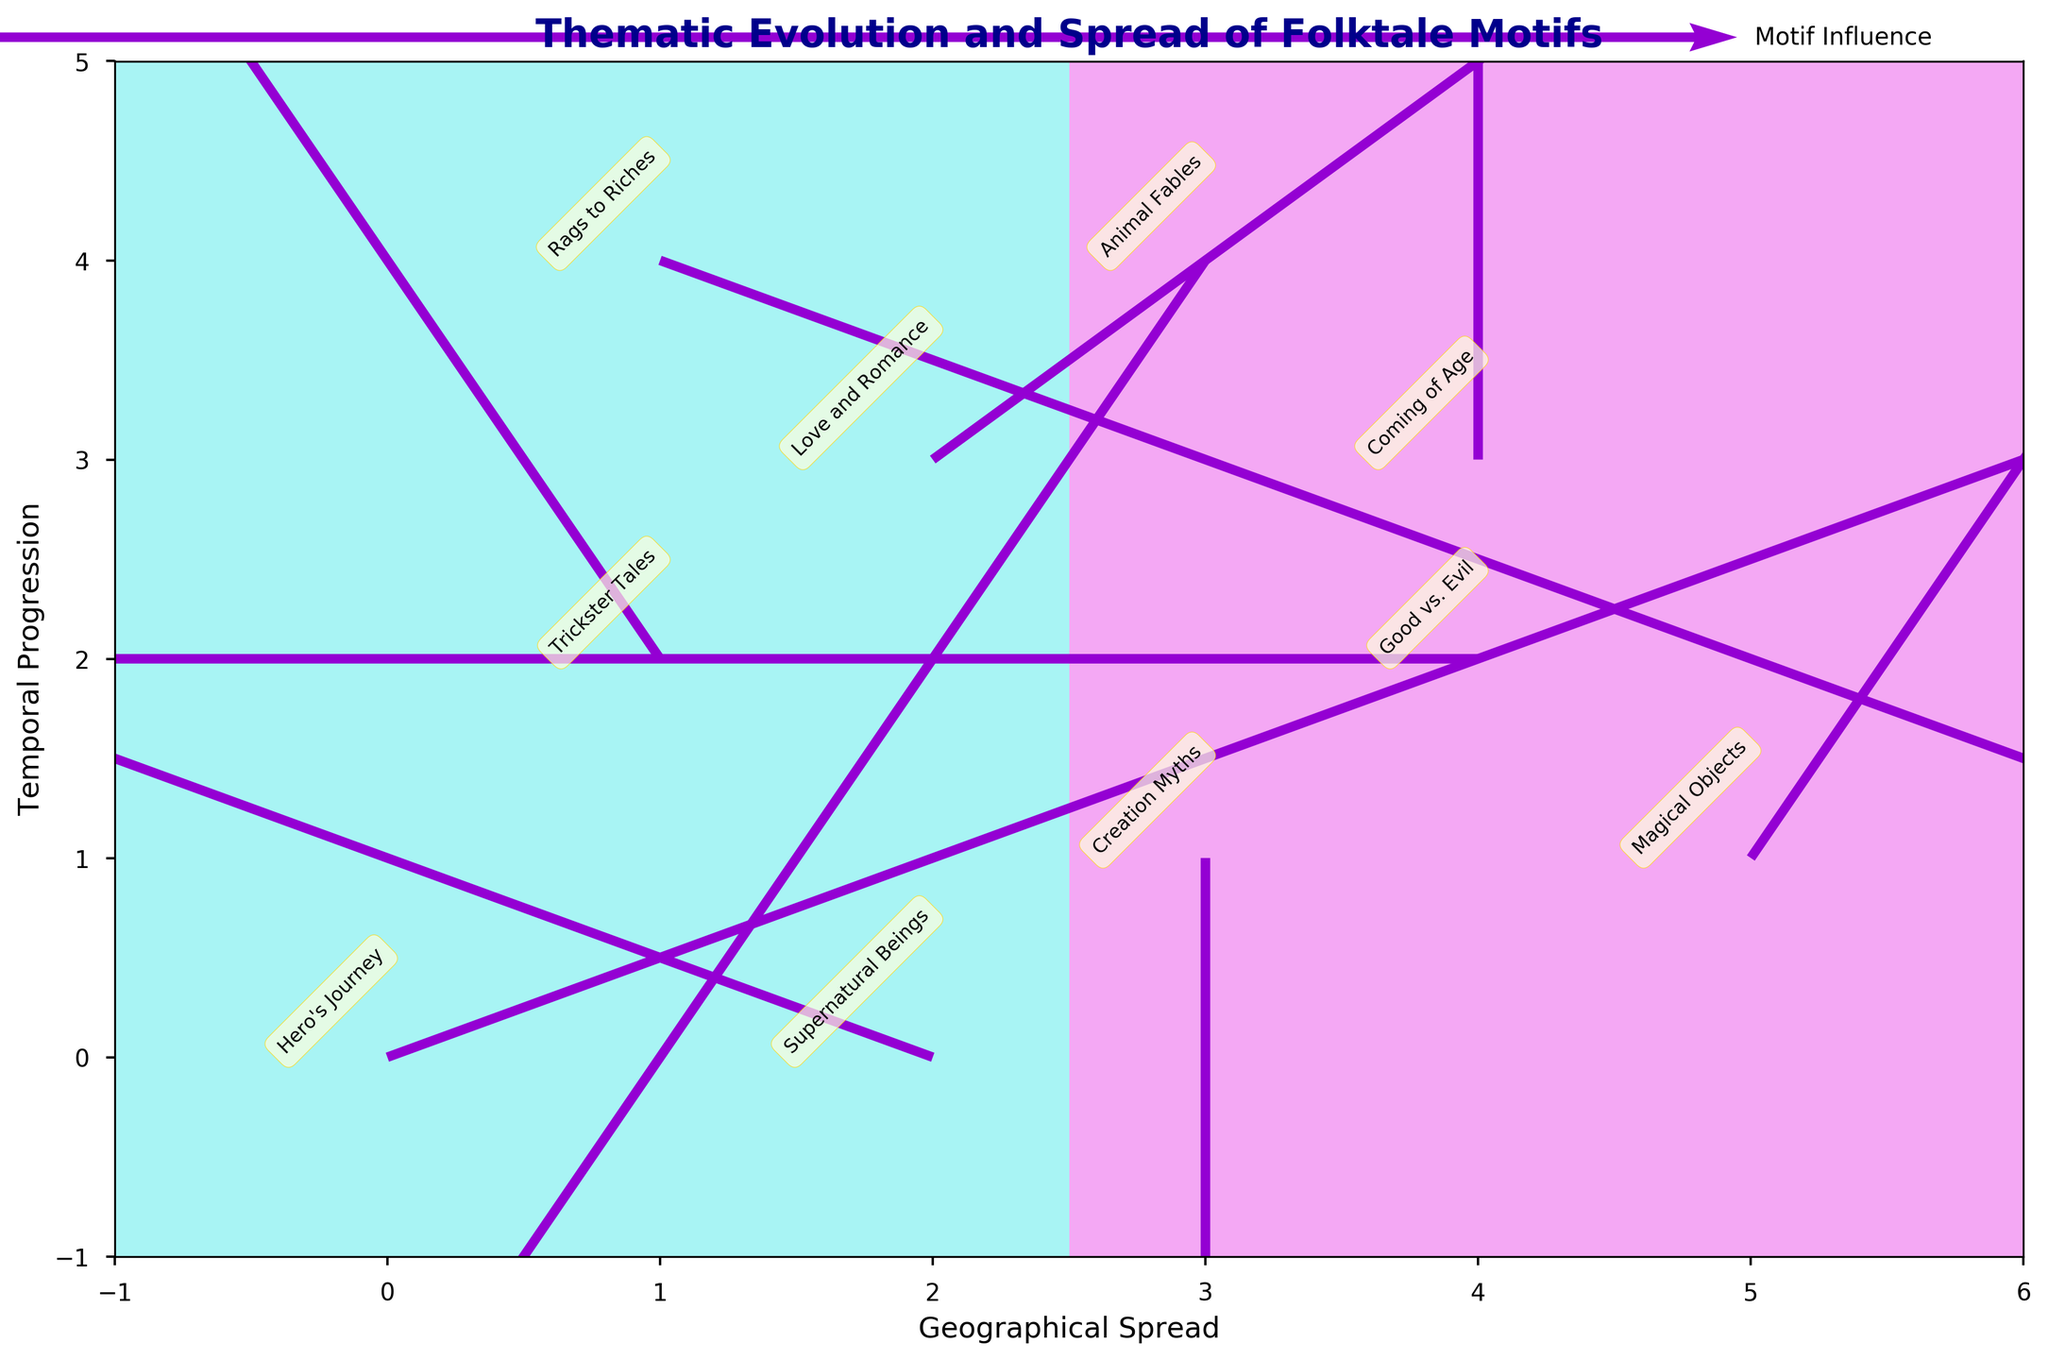How many themes are represented in the plot? Count the number of unique themes listed next to each arrow on the plot.
Answer: 10 What is the title of the plot? Look at the top of the plot for the title text.
Answer: Thematic Evolution and Spread of Folktale Motifs Which theme shows movement towards the left? Identify the arrows pointing towards the left, then check their respective labels; the arrow with U < 0 is "Trickster Tales".
Answer: Trickster Tales Which arrows are the longest? The length of the arrows represents their magnitude; visually compare the lengths and identify the longest ones.
Answer: Hero's Journey and Supernatural Beings Which theme experiences the greatest increase in 'Temporal Progression'? Look for the theme with the highest positive V value, which indicates the greatest upward movement; the theme is "Trickster Tales".
Answer: Trickster Tales Which motif influences both North and East directions? Identify arrows moving both up (V > 0) and to the right (U > 0); this is "Love and Romance".
Answer: Love and Romance How does the "Creation Myths" motif move over time? Look at the arrow labeled "Creation Myths" to determine its direction; this arrow points downwards indicating a decrease in 'Temporal Progression'.
Answer: Decreases in time What are the coordinates for the motif "Magical Objects"? Find "Magical Objects" on the plot and note the corresponding x and y coordinates; here, they are (5, 1).
Answer: (5, 1) Compare the directional movement between "Rags to Riches" and "Coming of Age". Examine the directions of both arrows; "Rags to Riches" moves down and to the right, whereas "Coming of Age" moves up vertically.
Answer: "Rags to Riches" moves down and right, "Coming of Age" moves up Which motif has no change in geographical spread but changes in time? Look for arrows with U = 0, meaning no left or right movement, and only a change in V; this is "Creation Myths".
Answer: Creation Myths 